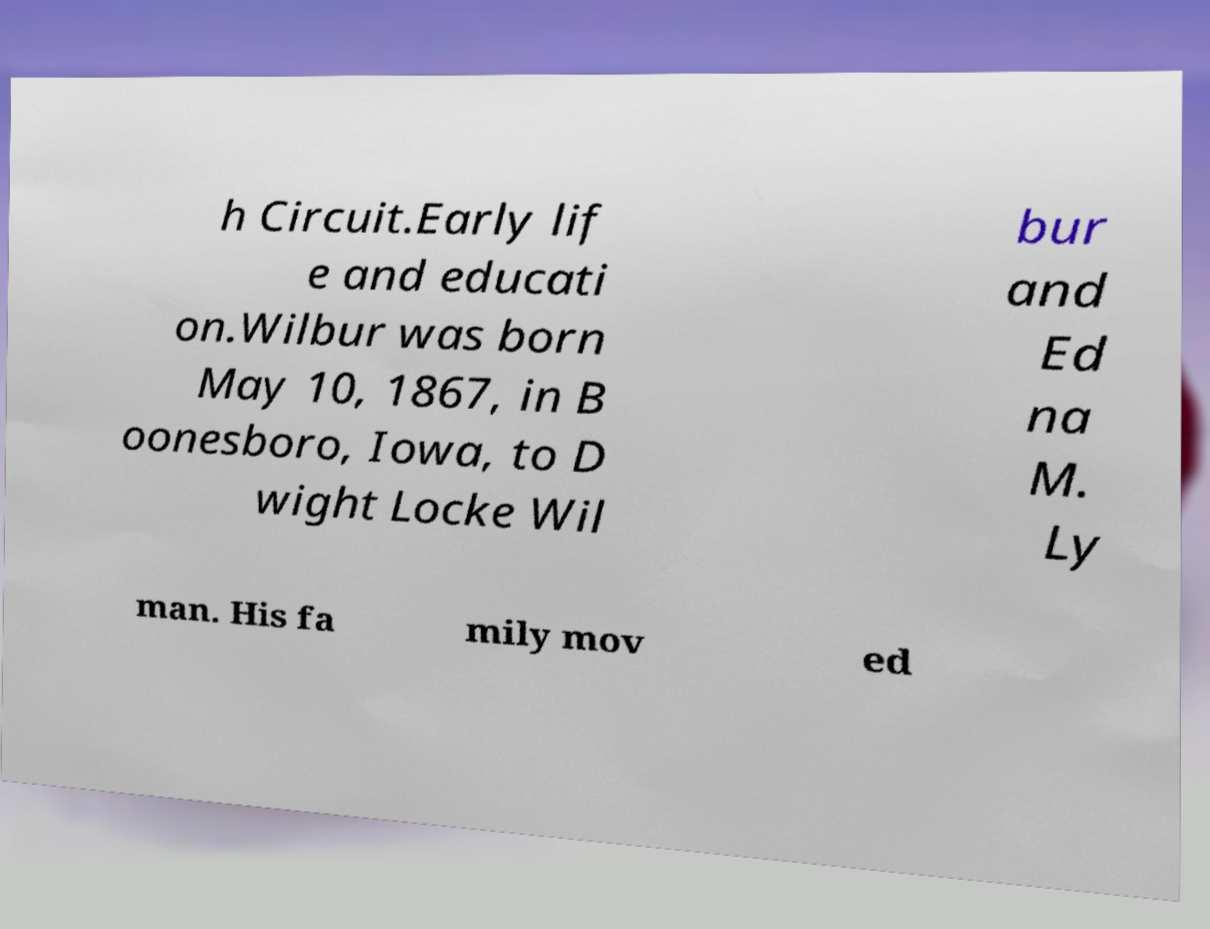Could you assist in decoding the text presented in this image and type it out clearly? h Circuit.Early lif e and educati on.Wilbur was born May 10, 1867, in B oonesboro, Iowa, to D wight Locke Wil bur and Ed na M. Ly man. His fa mily mov ed 